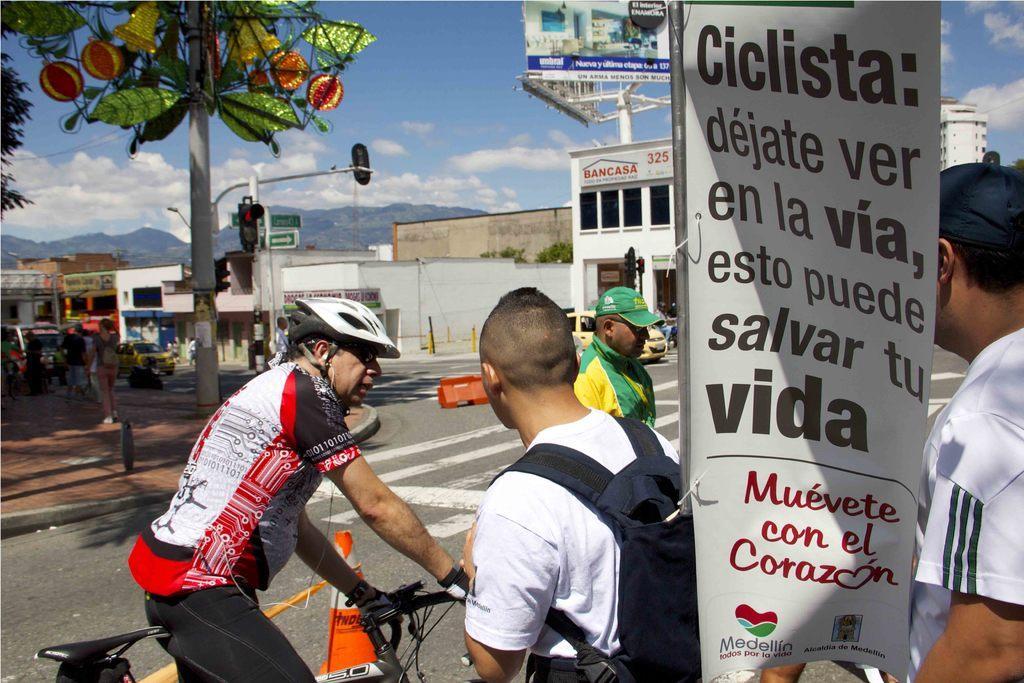In one or two sentences, can you explain what this image depicts? In this picture we can see four persons one person is holding bicycle wore helmet and other is carrying bag and here the person at back of banner and in background we can see houses, sky with clouds, traffic signal, some more persons, car, ground, hoarding, trees. 